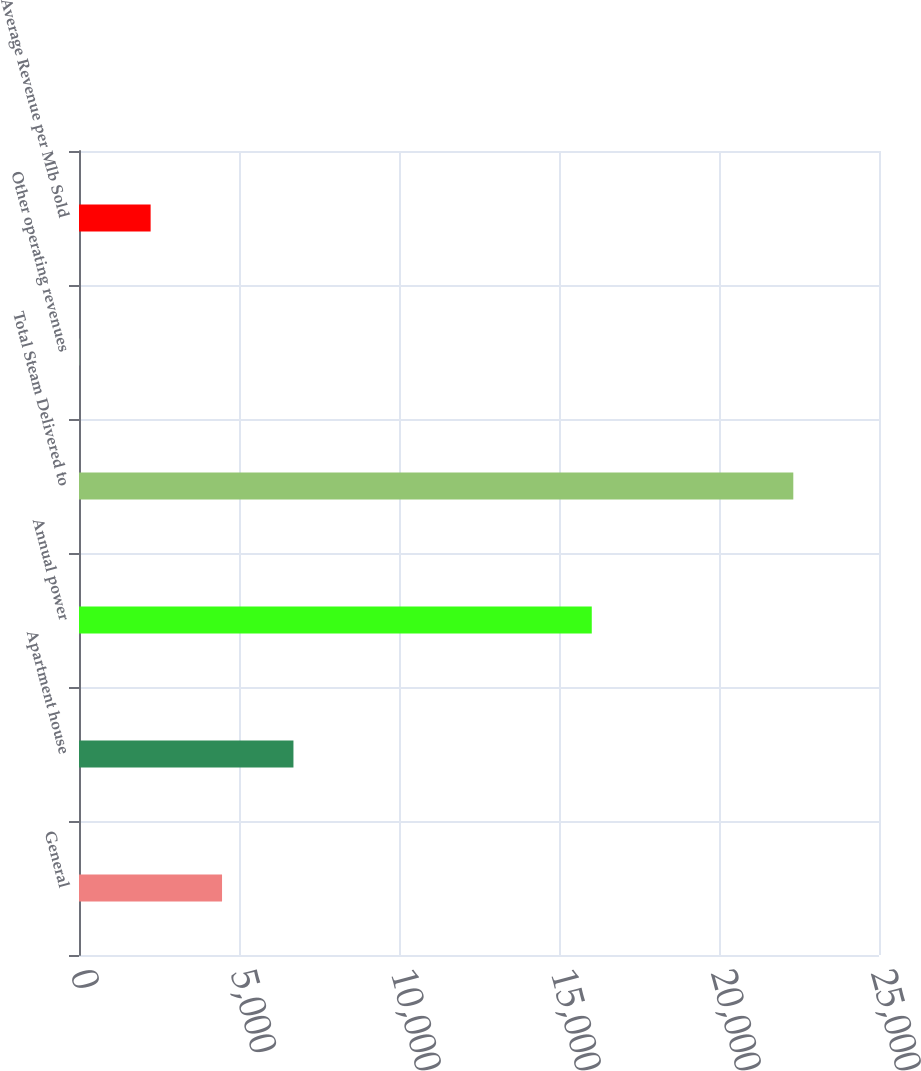Convert chart to OTSL. <chart><loc_0><loc_0><loc_500><loc_500><bar_chart><fcel>General<fcel>Apartment house<fcel>Annual power<fcel>Total Steam Delivered to<fcel>Other operating revenues<fcel>Average Revenue per Mlb Sold<nl><fcel>4470<fcel>6701.5<fcel>16024<fcel>22322<fcel>7<fcel>2238.5<nl></chart> 